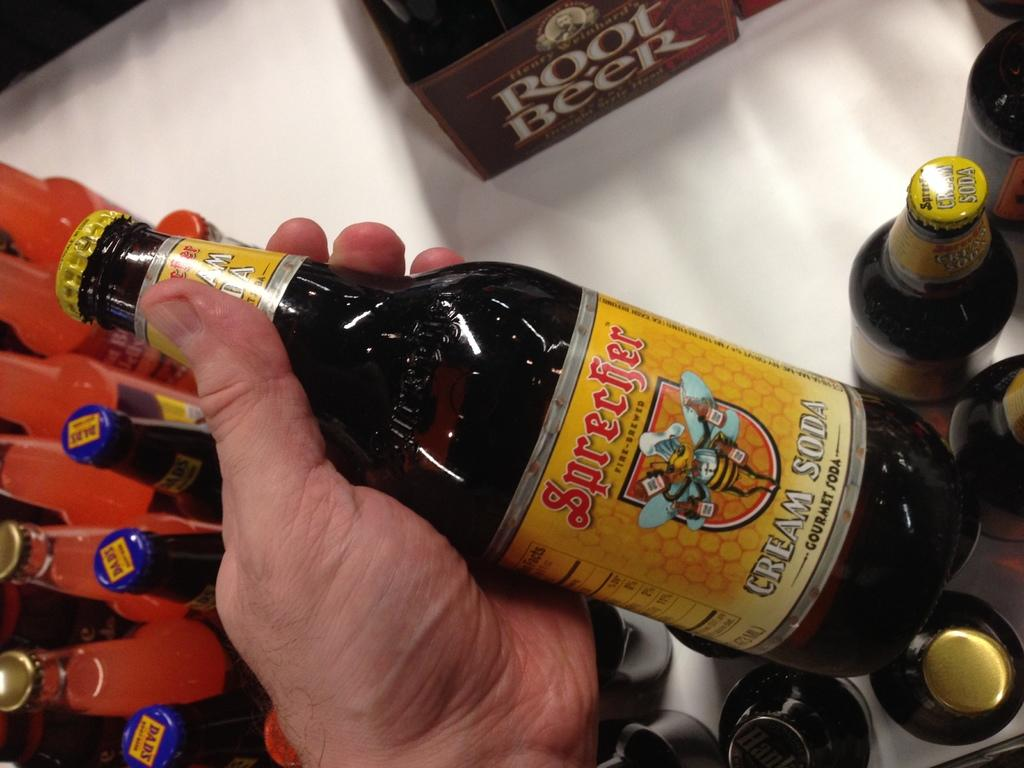<image>
Create a compact narrative representing the image presented. bottle of cream soda by the brand sprecfer root beer 